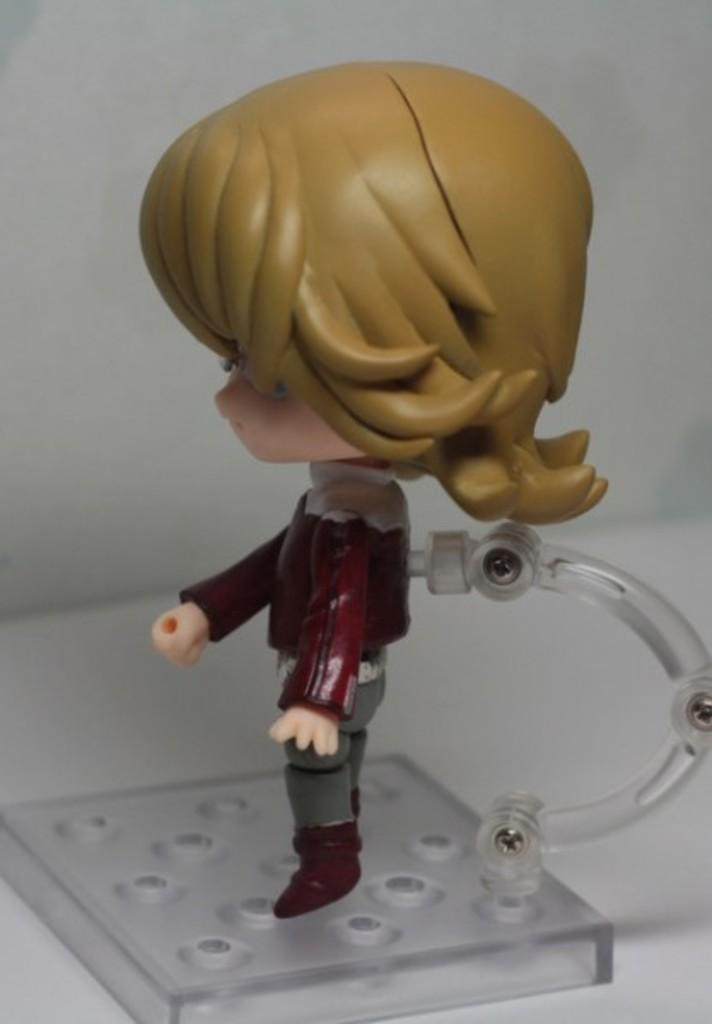What object can be seen in the image? There is a toy in the image. Where is the toy placed? The toy is on a white surface, which resembles a table. What can be seen in the background of the image? There is a white wall in the background of the image. What type of plane is flying in the image? There is no plane visible in the image; it only features a toy on a white surface and a white wall in the background. 